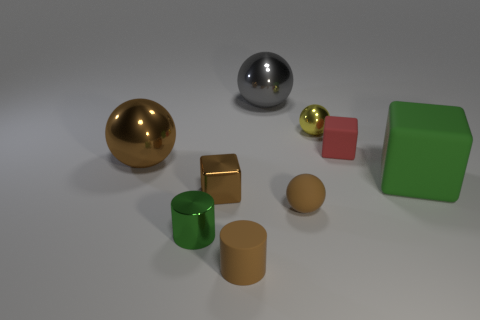Subtract all cyan balls. Subtract all blue blocks. How many balls are left? 4 Subtract all cylinders. How many objects are left? 7 Subtract 0 blue cylinders. How many objects are left? 9 Subtract all big metal spheres. Subtract all large green matte blocks. How many objects are left? 6 Add 4 big balls. How many big balls are left? 6 Add 9 large green rubber things. How many large green rubber things exist? 10 